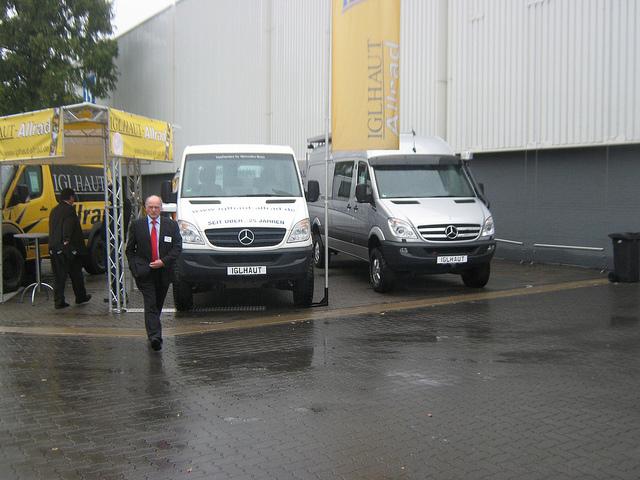Why does the tiled surface of this picture reflecting light?
Give a very brief answer. It's wet. How might a short-sighted friend recognize the man out front, even from far away?
Write a very short answer. Red tie. Is there snow on the ground?
Answer briefly. No. Are the two vehicles the same make?
Keep it brief. Yes. 